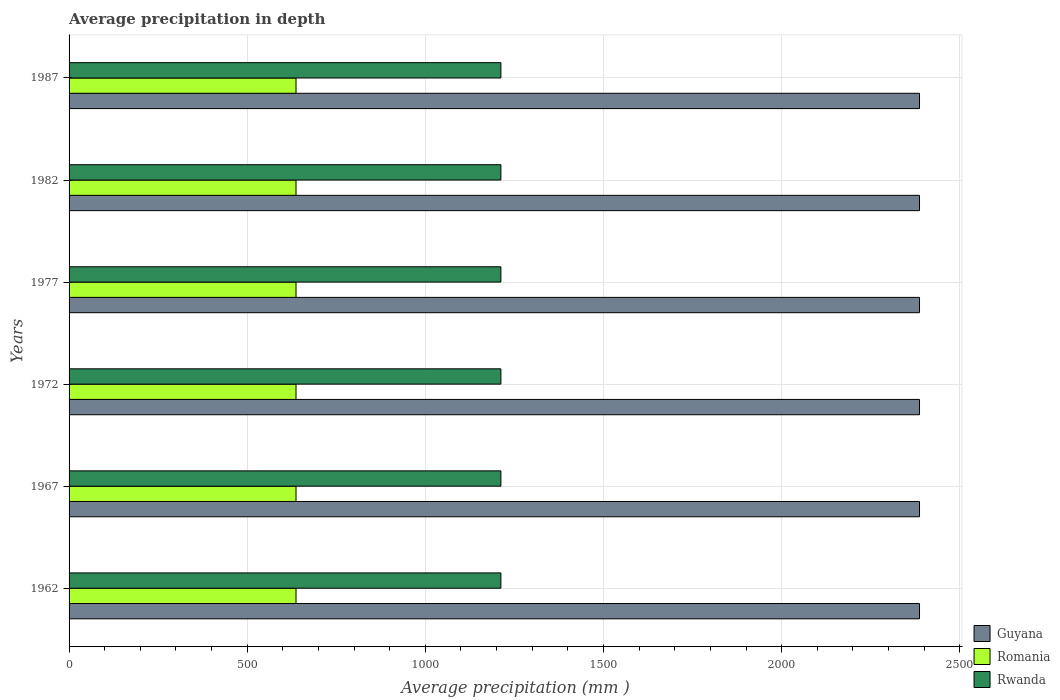How many different coloured bars are there?
Provide a short and direct response. 3. How many bars are there on the 4th tick from the bottom?
Keep it short and to the point. 3. What is the label of the 2nd group of bars from the top?
Make the answer very short. 1982. What is the average precipitation in Rwanda in 1962?
Provide a short and direct response. 1212. Across all years, what is the maximum average precipitation in Romania?
Give a very brief answer. 637. Across all years, what is the minimum average precipitation in Romania?
Offer a very short reply. 637. In which year was the average precipitation in Rwanda maximum?
Keep it short and to the point. 1962. What is the total average precipitation in Romania in the graph?
Ensure brevity in your answer.  3822. What is the difference between the average precipitation in Guyana in 1967 and that in 1982?
Offer a very short reply. 0. What is the difference between the average precipitation in Guyana in 1967 and the average precipitation in Rwanda in 1972?
Offer a terse response. 1175. What is the average average precipitation in Rwanda per year?
Provide a succinct answer. 1212. In the year 1987, what is the difference between the average precipitation in Rwanda and average precipitation in Romania?
Offer a terse response. 575. Is the average precipitation in Guyana in 1962 less than that in 1977?
Give a very brief answer. No. Is the difference between the average precipitation in Rwanda in 1967 and 1987 greater than the difference between the average precipitation in Romania in 1967 and 1987?
Ensure brevity in your answer.  No. What does the 2nd bar from the top in 1982 represents?
Keep it short and to the point. Romania. What does the 1st bar from the bottom in 1982 represents?
Provide a short and direct response. Guyana. Are all the bars in the graph horizontal?
Offer a very short reply. Yes. How many years are there in the graph?
Your response must be concise. 6. What is the difference between two consecutive major ticks on the X-axis?
Keep it short and to the point. 500. Are the values on the major ticks of X-axis written in scientific E-notation?
Your response must be concise. No. Where does the legend appear in the graph?
Provide a short and direct response. Bottom right. How many legend labels are there?
Your response must be concise. 3. How are the legend labels stacked?
Provide a succinct answer. Vertical. What is the title of the graph?
Provide a succinct answer. Average precipitation in depth. Does "OECD members" appear as one of the legend labels in the graph?
Provide a succinct answer. No. What is the label or title of the X-axis?
Offer a very short reply. Average precipitation (mm ). What is the Average precipitation (mm ) in Guyana in 1962?
Ensure brevity in your answer.  2387. What is the Average precipitation (mm ) in Romania in 1962?
Make the answer very short. 637. What is the Average precipitation (mm ) in Rwanda in 1962?
Give a very brief answer. 1212. What is the Average precipitation (mm ) in Guyana in 1967?
Give a very brief answer. 2387. What is the Average precipitation (mm ) in Romania in 1967?
Your answer should be very brief. 637. What is the Average precipitation (mm ) in Rwanda in 1967?
Offer a terse response. 1212. What is the Average precipitation (mm ) of Guyana in 1972?
Your response must be concise. 2387. What is the Average precipitation (mm ) of Romania in 1972?
Offer a terse response. 637. What is the Average precipitation (mm ) in Rwanda in 1972?
Give a very brief answer. 1212. What is the Average precipitation (mm ) in Guyana in 1977?
Offer a very short reply. 2387. What is the Average precipitation (mm ) of Romania in 1977?
Offer a very short reply. 637. What is the Average precipitation (mm ) in Rwanda in 1977?
Your response must be concise. 1212. What is the Average precipitation (mm ) of Guyana in 1982?
Offer a terse response. 2387. What is the Average precipitation (mm ) in Romania in 1982?
Offer a terse response. 637. What is the Average precipitation (mm ) in Rwanda in 1982?
Provide a succinct answer. 1212. What is the Average precipitation (mm ) of Guyana in 1987?
Give a very brief answer. 2387. What is the Average precipitation (mm ) of Romania in 1987?
Keep it short and to the point. 637. What is the Average precipitation (mm ) of Rwanda in 1987?
Make the answer very short. 1212. Across all years, what is the maximum Average precipitation (mm ) in Guyana?
Ensure brevity in your answer.  2387. Across all years, what is the maximum Average precipitation (mm ) of Romania?
Make the answer very short. 637. Across all years, what is the maximum Average precipitation (mm ) of Rwanda?
Offer a very short reply. 1212. Across all years, what is the minimum Average precipitation (mm ) of Guyana?
Keep it short and to the point. 2387. Across all years, what is the minimum Average precipitation (mm ) in Romania?
Give a very brief answer. 637. Across all years, what is the minimum Average precipitation (mm ) of Rwanda?
Make the answer very short. 1212. What is the total Average precipitation (mm ) of Guyana in the graph?
Keep it short and to the point. 1.43e+04. What is the total Average precipitation (mm ) in Romania in the graph?
Your response must be concise. 3822. What is the total Average precipitation (mm ) of Rwanda in the graph?
Your response must be concise. 7272. What is the difference between the Average precipitation (mm ) in Romania in 1962 and that in 1967?
Make the answer very short. 0. What is the difference between the Average precipitation (mm ) of Guyana in 1962 and that in 1972?
Ensure brevity in your answer.  0. What is the difference between the Average precipitation (mm ) in Guyana in 1962 and that in 1977?
Your answer should be compact. 0. What is the difference between the Average precipitation (mm ) of Guyana in 1962 and that in 1982?
Make the answer very short. 0. What is the difference between the Average precipitation (mm ) of Romania in 1962 and that in 1982?
Your answer should be compact. 0. What is the difference between the Average precipitation (mm ) of Rwanda in 1962 and that in 1982?
Offer a terse response. 0. What is the difference between the Average precipitation (mm ) of Guyana in 1962 and that in 1987?
Make the answer very short. 0. What is the difference between the Average precipitation (mm ) in Romania in 1962 and that in 1987?
Offer a terse response. 0. What is the difference between the Average precipitation (mm ) of Rwanda in 1962 and that in 1987?
Your answer should be compact. 0. What is the difference between the Average precipitation (mm ) in Romania in 1967 and that in 1972?
Provide a succinct answer. 0. What is the difference between the Average precipitation (mm ) in Romania in 1967 and that in 1977?
Your answer should be compact. 0. What is the difference between the Average precipitation (mm ) of Guyana in 1967 and that in 1982?
Provide a succinct answer. 0. What is the difference between the Average precipitation (mm ) of Guyana in 1967 and that in 1987?
Ensure brevity in your answer.  0. What is the difference between the Average precipitation (mm ) in Romania in 1967 and that in 1987?
Keep it short and to the point. 0. What is the difference between the Average precipitation (mm ) in Rwanda in 1967 and that in 1987?
Your answer should be compact. 0. What is the difference between the Average precipitation (mm ) in Romania in 1972 and that in 1977?
Your answer should be compact. 0. What is the difference between the Average precipitation (mm ) of Rwanda in 1972 and that in 1977?
Ensure brevity in your answer.  0. What is the difference between the Average precipitation (mm ) of Guyana in 1972 and that in 1982?
Your answer should be compact. 0. What is the difference between the Average precipitation (mm ) of Romania in 1972 and that in 1982?
Make the answer very short. 0. What is the difference between the Average precipitation (mm ) in Rwanda in 1972 and that in 1982?
Keep it short and to the point. 0. What is the difference between the Average precipitation (mm ) of Guyana in 1972 and that in 1987?
Give a very brief answer. 0. What is the difference between the Average precipitation (mm ) of Romania in 1972 and that in 1987?
Provide a short and direct response. 0. What is the difference between the Average precipitation (mm ) of Rwanda in 1972 and that in 1987?
Offer a terse response. 0. What is the difference between the Average precipitation (mm ) of Guyana in 1977 and that in 1982?
Your response must be concise. 0. What is the difference between the Average precipitation (mm ) of Rwanda in 1977 and that in 1982?
Make the answer very short. 0. What is the difference between the Average precipitation (mm ) of Guyana in 1977 and that in 1987?
Your answer should be very brief. 0. What is the difference between the Average precipitation (mm ) of Rwanda in 1977 and that in 1987?
Your response must be concise. 0. What is the difference between the Average precipitation (mm ) in Romania in 1982 and that in 1987?
Give a very brief answer. 0. What is the difference between the Average precipitation (mm ) of Guyana in 1962 and the Average precipitation (mm ) of Romania in 1967?
Provide a succinct answer. 1750. What is the difference between the Average precipitation (mm ) in Guyana in 1962 and the Average precipitation (mm ) in Rwanda in 1967?
Make the answer very short. 1175. What is the difference between the Average precipitation (mm ) in Romania in 1962 and the Average precipitation (mm ) in Rwanda in 1967?
Give a very brief answer. -575. What is the difference between the Average precipitation (mm ) of Guyana in 1962 and the Average precipitation (mm ) of Romania in 1972?
Provide a short and direct response. 1750. What is the difference between the Average precipitation (mm ) in Guyana in 1962 and the Average precipitation (mm ) in Rwanda in 1972?
Offer a very short reply. 1175. What is the difference between the Average precipitation (mm ) of Romania in 1962 and the Average precipitation (mm ) of Rwanda in 1972?
Your response must be concise. -575. What is the difference between the Average precipitation (mm ) in Guyana in 1962 and the Average precipitation (mm ) in Romania in 1977?
Your answer should be very brief. 1750. What is the difference between the Average precipitation (mm ) in Guyana in 1962 and the Average precipitation (mm ) in Rwanda in 1977?
Provide a succinct answer. 1175. What is the difference between the Average precipitation (mm ) in Romania in 1962 and the Average precipitation (mm ) in Rwanda in 1977?
Offer a terse response. -575. What is the difference between the Average precipitation (mm ) in Guyana in 1962 and the Average precipitation (mm ) in Romania in 1982?
Provide a short and direct response. 1750. What is the difference between the Average precipitation (mm ) of Guyana in 1962 and the Average precipitation (mm ) of Rwanda in 1982?
Offer a terse response. 1175. What is the difference between the Average precipitation (mm ) of Romania in 1962 and the Average precipitation (mm ) of Rwanda in 1982?
Give a very brief answer. -575. What is the difference between the Average precipitation (mm ) in Guyana in 1962 and the Average precipitation (mm ) in Romania in 1987?
Offer a very short reply. 1750. What is the difference between the Average precipitation (mm ) of Guyana in 1962 and the Average precipitation (mm ) of Rwanda in 1987?
Offer a terse response. 1175. What is the difference between the Average precipitation (mm ) of Romania in 1962 and the Average precipitation (mm ) of Rwanda in 1987?
Provide a succinct answer. -575. What is the difference between the Average precipitation (mm ) in Guyana in 1967 and the Average precipitation (mm ) in Romania in 1972?
Keep it short and to the point. 1750. What is the difference between the Average precipitation (mm ) in Guyana in 1967 and the Average precipitation (mm ) in Rwanda in 1972?
Provide a succinct answer. 1175. What is the difference between the Average precipitation (mm ) in Romania in 1967 and the Average precipitation (mm ) in Rwanda in 1972?
Provide a short and direct response. -575. What is the difference between the Average precipitation (mm ) of Guyana in 1967 and the Average precipitation (mm ) of Romania in 1977?
Make the answer very short. 1750. What is the difference between the Average precipitation (mm ) of Guyana in 1967 and the Average precipitation (mm ) of Rwanda in 1977?
Provide a short and direct response. 1175. What is the difference between the Average precipitation (mm ) of Romania in 1967 and the Average precipitation (mm ) of Rwanda in 1977?
Keep it short and to the point. -575. What is the difference between the Average precipitation (mm ) in Guyana in 1967 and the Average precipitation (mm ) in Romania in 1982?
Your answer should be very brief. 1750. What is the difference between the Average precipitation (mm ) of Guyana in 1967 and the Average precipitation (mm ) of Rwanda in 1982?
Make the answer very short. 1175. What is the difference between the Average precipitation (mm ) of Romania in 1967 and the Average precipitation (mm ) of Rwanda in 1982?
Provide a succinct answer. -575. What is the difference between the Average precipitation (mm ) in Guyana in 1967 and the Average precipitation (mm ) in Romania in 1987?
Offer a very short reply. 1750. What is the difference between the Average precipitation (mm ) of Guyana in 1967 and the Average precipitation (mm ) of Rwanda in 1987?
Your answer should be very brief. 1175. What is the difference between the Average precipitation (mm ) of Romania in 1967 and the Average precipitation (mm ) of Rwanda in 1987?
Your response must be concise. -575. What is the difference between the Average precipitation (mm ) in Guyana in 1972 and the Average precipitation (mm ) in Romania in 1977?
Make the answer very short. 1750. What is the difference between the Average precipitation (mm ) of Guyana in 1972 and the Average precipitation (mm ) of Rwanda in 1977?
Offer a terse response. 1175. What is the difference between the Average precipitation (mm ) in Romania in 1972 and the Average precipitation (mm ) in Rwanda in 1977?
Keep it short and to the point. -575. What is the difference between the Average precipitation (mm ) in Guyana in 1972 and the Average precipitation (mm ) in Romania in 1982?
Make the answer very short. 1750. What is the difference between the Average precipitation (mm ) in Guyana in 1972 and the Average precipitation (mm ) in Rwanda in 1982?
Provide a succinct answer. 1175. What is the difference between the Average precipitation (mm ) in Romania in 1972 and the Average precipitation (mm ) in Rwanda in 1982?
Provide a short and direct response. -575. What is the difference between the Average precipitation (mm ) in Guyana in 1972 and the Average precipitation (mm ) in Romania in 1987?
Provide a short and direct response. 1750. What is the difference between the Average precipitation (mm ) of Guyana in 1972 and the Average precipitation (mm ) of Rwanda in 1987?
Offer a terse response. 1175. What is the difference between the Average precipitation (mm ) in Romania in 1972 and the Average precipitation (mm ) in Rwanda in 1987?
Provide a short and direct response. -575. What is the difference between the Average precipitation (mm ) in Guyana in 1977 and the Average precipitation (mm ) in Romania in 1982?
Offer a very short reply. 1750. What is the difference between the Average precipitation (mm ) of Guyana in 1977 and the Average precipitation (mm ) of Rwanda in 1982?
Your answer should be compact. 1175. What is the difference between the Average precipitation (mm ) in Romania in 1977 and the Average precipitation (mm ) in Rwanda in 1982?
Your answer should be compact. -575. What is the difference between the Average precipitation (mm ) in Guyana in 1977 and the Average precipitation (mm ) in Romania in 1987?
Your response must be concise. 1750. What is the difference between the Average precipitation (mm ) in Guyana in 1977 and the Average precipitation (mm ) in Rwanda in 1987?
Offer a very short reply. 1175. What is the difference between the Average precipitation (mm ) in Romania in 1977 and the Average precipitation (mm ) in Rwanda in 1987?
Keep it short and to the point. -575. What is the difference between the Average precipitation (mm ) of Guyana in 1982 and the Average precipitation (mm ) of Romania in 1987?
Your answer should be very brief. 1750. What is the difference between the Average precipitation (mm ) in Guyana in 1982 and the Average precipitation (mm ) in Rwanda in 1987?
Your answer should be very brief. 1175. What is the difference between the Average precipitation (mm ) of Romania in 1982 and the Average precipitation (mm ) of Rwanda in 1987?
Offer a very short reply. -575. What is the average Average precipitation (mm ) in Guyana per year?
Provide a short and direct response. 2387. What is the average Average precipitation (mm ) in Romania per year?
Provide a succinct answer. 637. What is the average Average precipitation (mm ) in Rwanda per year?
Give a very brief answer. 1212. In the year 1962, what is the difference between the Average precipitation (mm ) in Guyana and Average precipitation (mm ) in Romania?
Provide a succinct answer. 1750. In the year 1962, what is the difference between the Average precipitation (mm ) in Guyana and Average precipitation (mm ) in Rwanda?
Offer a very short reply. 1175. In the year 1962, what is the difference between the Average precipitation (mm ) in Romania and Average precipitation (mm ) in Rwanda?
Your answer should be very brief. -575. In the year 1967, what is the difference between the Average precipitation (mm ) in Guyana and Average precipitation (mm ) in Romania?
Offer a very short reply. 1750. In the year 1967, what is the difference between the Average precipitation (mm ) in Guyana and Average precipitation (mm ) in Rwanda?
Make the answer very short. 1175. In the year 1967, what is the difference between the Average precipitation (mm ) in Romania and Average precipitation (mm ) in Rwanda?
Keep it short and to the point. -575. In the year 1972, what is the difference between the Average precipitation (mm ) of Guyana and Average precipitation (mm ) of Romania?
Your answer should be compact. 1750. In the year 1972, what is the difference between the Average precipitation (mm ) in Guyana and Average precipitation (mm ) in Rwanda?
Offer a very short reply. 1175. In the year 1972, what is the difference between the Average precipitation (mm ) in Romania and Average precipitation (mm ) in Rwanda?
Your response must be concise. -575. In the year 1977, what is the difference between the Average precipitation (mm ) in Guyana and Average precipitation (mm ) in Romania?
Give a very brief answer. 1750. In the year 1977, what is the difference between the Average precipitation (mm ) in Guyana and Average precipitation (mm ) in Rwanda?
Ensure brevity in your answer.  1175. In the year 1977, what is the difference between the Average precipitation (mm ) in Romania and Average precipitation (mm ) in Rwanda?
Offer a terse response. -575. In the year 1982, what is the difference between the Average precipitation (mm ) of Guyana and Average precipitation (mm ) of Romania?
Your answer should be very brief. 1750. In the year 1982, what is the difference between the Average precipitation (mm ) in Guyana and Average precipitation (mm ) in Rwanda?
Keep it short and to the point. 1175. In the year 1982, what is the difference between the Average precipitation (mm ) in Romania and Average precipitation (mm ) in Rwanda?
Your answer should be very brief. -575. In the year 1987, what is the difference between the Average precipitation (mm ) of Guyana and Average precipitation (mm ) of Romania?
Give a very brief answer. 1750. In the year 1987, what is the difference between the Average precipitation (mm ) in Guyana and Average precipitation (mm ) in Rwanda?
Make the answer very short. 1175. In the year 1987, what is the difference between the Average precipitation (mm ) of Romania and Average precipitation (mm ) of Rwanda?
Keep it short and to the point. -575. What is the ratio of the Average precipitation (mm ) in Guyana in 1962 to that in 1967?
Give a very brief answer. 1. What is the ratio of the Average precipitation (mm ) of Rwanda in 1962 to that in 1967?
Provide a short and direct response. 1. What is the ratio of the Average precipitation (mm ) of Guyana in 1962 to that in 1972?
Offer a terse response. 1. What is the ratio of the Average precipitation (mm ) in Guyana in 1962 to that in 1977?
Your answer should be very brief. 1. What is the ratio of the Average precipitation (mm ) in Romania in 1962 to that in 1977?
Keep it short and to the point. 1. What is the ratio of the Average precipitation (mm ) of Romania in 1962 to that in 1982?
Provide a short and direct response. 1. What is the ratio of the Average precipitation (mm ) in Rwanda in 1962 to that in 1982?
Offer a terse response. 1. What is the ratio of the Average precipitation (mm ) in Romania in 1962 to that in 1987?
Give a very brief answer. 1. What is the ratio of the Average precipitation (mm ) of Guyana in 1967 to that in 1972?
Your response must be concise. 1. What is the ratio of the Average precipitation (mm ) in Rwanda in 1967 to that in 1977?
Offer a very short reply. 1. What is the ratio of the Average precipitation (mm ) of Guyana in 1967 to that in 1982?
Provide a succinct answer. 1. What is the ratio of the Average precipitation (mm ) of Romania in 1967 to that in 1982?
Give a very brief answer. 1. What is the ratio of the Average precipitation (mm ) of Rwanda in 1967 to that in 1982?
Your answer should be very brief. 1. What is the ratio of the Average precipitation (mm ) in Guyana in 1967 to that in 1987?
Ensure brevity in your answer.  1. What is the ratio of the Average precipitation (mm ) in Romania in 1967 to that in 1987?
Make the answer very short. 1. What is the ratio of the Average precipitation (mm ) in Guyana in 1972 to that in 1977?
Ensure brevity in your answer.  1. What is the ratio of the Average precipitation (mm ) of Rwanda in 1972 to that in 1977?
Provide a short and direct response. 1. What is the ratio of the Average precipitation (mm ) in Rwanda in 1972 to that in 1982?
Your answer should be compact. 1. What is the ratio of the Average precipitation (mm ) of Romania in 1972 to that in 1987?
Keep it short and to the point. 1. What is the ratio of the Average precipitation (mm ) of Rwanda in 1972 to that in 1987?
Give a very brief answer. 1. What is the ratio of the Average precipitation (mm ) in Romania in 1977 to that in 1982?
Give a very brief answer. 1. What is the ratio of the Average precipitation (mm ) of Guyana in 1982 to that in 1987?
Offer a very short reply. 1. What is the ratio of the Average precipitation (mm ) of Rwanda in 1982 to that in 1987?
Give a very brief answer. 1. What is the difference between the highest and the second highest Average precipitation (mm ) of Guyana?
Your answer should be compact. 0. What is the difference between the highest and the lowest Average precipitation (mm ) of Guyana?
Your answer should be very brief. 0. What is the difference between the highest and the lowest Average precipitation (mm ) of Romania?
Your answer should be very brief. 0. What is the difference between the highest and the lowest Average precipitation (mm ) of Rwanda?
Give a very brief answer. 0. 